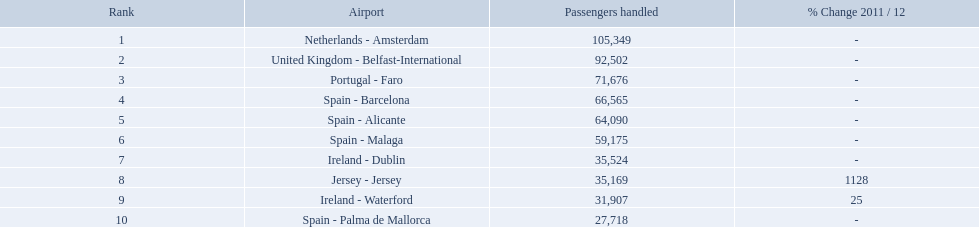Can you parse all the data within this table? {'header': ['Rank', 'Airport', 'Passengers handled', '% Change 2011 / 12'], 'rows': [['1', 'Netherlands - Amsterdam', '105,349', '-'], ['2', 'United Kingdom - Belfast-International', '92,502', '-'], ['3', 'Portugal - Faro', '71,676', '-'], ['4', 'Spain - Barcelona', '66,565', '-'], ['5', 'Spain - Alicante', '64,090', '-'], ['6', 'Spain - Malaga', '59,175', '-'], ['7', 'Ireland - Dublin', '35,524', '-'], ['8', 'Jersey - Jersey', '35,169', '1128'], ['9', 'Ireland - Waterford', '31,907', '25'], ['10', 'Spain - Palma de Mallorca', '27,718', '-']]} What are the airports? Netherlands - Amsterdam, United Kingdom - Belfast-International, Portugal - Faro, Spain - Barcelona, Spain - Alicante, Spain - Malaga, Ireland - Dublin, Jersey - Jersey, Ireland - Waterford, Spain - Palma de Mallorca. Of these which has the least amount of passengers? Spain - Palma de Mallorca. Which airports had passengers going through london southend airport? Netherlands - Amsterdam, United Kingdom - Belfast-International, Portugal - Faro, Spain - Barcelona, Spain - Alicante, Spain - Malaga, Ireland - Dublin, Jersey - Jersey, Ireland - Waterford, Spain - Palma de Mallorca. Of those airports, which airport had the least amount of passengers going through london southend airport? Spain - Palma de Mallorca. What are all of the airports? Netherlands - Amsterdam, United Kingdom - Belfast-International, Portugal - Faro, Spain - Barcelona, Spain - Alicante, Spain - Malaga, Ireland - Dublin, Jersey - Jersey, Ireland - Waterford, Spain - Palma de Mallorca. How many passengers have they handled? 105,349, 92,502, 71,676, 66,565, 64,090, 59,175, 35,524, 35,169, 31,907, 27,718. And which airport has handled the most passengers? Netherlands - Amsterdam. Which airports are in europe? Netherlands - Amsterdam, United Kingdom - Belfast-International, Portugal - Faro, Spain - Barcelona, Spain - Alicante, Spain - Malaga, Ireland - Dublin, Ireland - Waterford, Spain - Palma de Mallorca. Which one is from portugal? Portugal - Faro. What are all the airports in the top 10 busiest routes to and from london southend airport? Netherlands - Amsterdam, United Kingdom - Belfast-International, Portugal - Faro, Spain - Barcelona, Spain - Alicante, Spain - Malaga, Ireland - Dublin, Jersey - Jersey, Ireland - Waterford, Spain - Palma de Mallorca. Which airports are in portugal? Portugal - Faro. Would you be able to parse every entry in this table? {'header': ['Rank', 'Airport', 'Passengers handled', '% Change 2011 / 12'], 'rows': [['1', 'Netherlands - Amsterdam', '105,349', '-'], ['2', 'United Kingdom - Belfast-International', '92,502', '-'], ['3', 'Portugal - Faro', '71,676', '-'], ['4', 'Spain - Barcelona', '66,565', '-'], ['5', 'Spain - Alicante', '64,090', '-'], ['6', 'Spain - Malaga', '59,175', '-'], ['7', 'Ireland - Dublin', '35,524', '-'], ['8', 'Jersey - Jersey', '35,169', '1128'], ['9', 'Ireland - Waterford', '31,907', '25'], ['10', 'Spain - Palma de Mallorca', '27,718', '-']]} What is the highest number of passengers handled? 105,349. What is the destination of the passengers leaving the area that handles 105,349 travellers? Netherlands - Amsterdam. What are all of the routes out of the london southend airport? Netherlands - Amsterdam, United Kingdom - Belfast-International, Portugal - Faro, Spain - Barcelona, Spain - Alicante, Spain - Malaga, Ireland - Dublin, Jersey - Jersey, Ireland - Waterford, Spain - Palma de Mallorca. How many passengers have traveled to each destination? 105,349, 92,502, 71,676, 66,565, 64,090, 59,175, 35,524, 35,169, 31,907, 27,718. And which destination has been the most popular to passengers? Netherlands - Amsterdam. What is the highest number of passengers handled? 105,349. What is the destination of the passengers leaving the area that handles 105,349 travellers? Netherlands - Amsterdam. How many passengers did the united kingdom handle? 92,502. Who handled more passengers than this? Netherlands - Amsterdam. What are the appellations of all the airports? Netherlands - Amsterdam, United Kingdom - Belfast-International, Portugal - Faro, Spain - Barcelona, Spain - Alicante, Spain - Malaga, Ireland - Dublin, Jersey - Jersey, Ireland - Waterford, Spain - Palma de Mallorca. Of these, what are the complete passenger quantities? 105,349, 92,502, 71,676, 66,565, 64,090, 59,175, 35,524, 35,169, 31,907, 27,718. Of these, which airport had a greater number of passengers than the united kingdom? Netherlands - Amsterdam. Which airports had travelers passing through london southend airport? Netherlands - Amsterdam, United Kingdom - Belfast-International, Portugal - Faro, Spain - Barcelona, Spain - Alicante, Spain - Malaga, Ireland - Dublin, Jersey - Jersey, Ireland - Waterford, Spain - Palma de Mallorca. Among those airports, which one had the smallest number of passengers passing through london southend airport? Spain - Palma de Mallorca. What are the airports? Netherlands - Amsterdam, United Kingdom - Belfast-International, Portugal - Faro, Spain - Barcelona, Spain - Alicante, Spain - Malaga, Ireland - Dublin, Jersey - Jersey, Ireland - Waterford, Spain - Palma de Mallorca. Among them, which has the smallest volume of passengers? Spain - Palma de Mallorca. What is the highest rank? 1. What is the airstrip? Netherlands - Amsterdam. Could you help me parse every detail presented in this table? {'header': ['Rank', 'Airport', 'Passengers handled', '% Change 2011 / 12'], 'rows': [['1', 'Netherlands - Amsterdam', '105,349', '-'], ['2', 'United Kingdom - Belfast-International', '92,502', '-'], ['3', 'Portugal - Faro', '71,676', '-'], ['4', 'Spain - Barcelona', '66,565', '-'], ['5', 'Spain - Alicante', '64,090', '-'], ['6', 'Spain - Malaga', '59,175', '-'], ['7', 'Ireland - Dublin', '35,524', '-'], ['8', 'Jersey - Jersey', '35,169', '1128'], ['9', 'Ireland - Waterford', '31,907', '25'], ['10', 'Spain - Palma de Mallorca', '27,718', '-']]} How many individuals did the united kingdom process as passengers? 92,502. Who processed more passengers than this? Netherlands - Amsterdam. What are every destination from the london southend airport? Netherlands - Amsterdam, United Kingdom - Belfast-International, Portugal - Faro, Spain - Barcelona, Spain - Alicante, Spain - Malaga, Ireland - Dublin, Jersey - Jersey, Ireland - Waterford, Spain - Palma de Mallorca. How many individuals have been handled by each destination? 105,349, 92,502, 71,676, 66,565, 64,090, 59,175, 35,524, 35,169, 31,907, 27,718. And from those, which airport dealt with the smallest number of passengers? Spain - Palma de Mallorca. What is the greatest number of passengers dealt with? 105,349. What is the target location of the passengers leaving the region that processes 105,349 journeyers? Netherlands - Amsterdam. What are all the airports? Netherlands - Amsterdam, United Kingdom - Belfast-International, Portugal - Faro, Spain - Barcelona, Spain - Alicante, Spain - Malaga, Ireland - Dublin, Jersey - Jersey, Ireland - Waterford, Spain - Palma de Mallorca. How many passengers have they managed? 105,349, 92,502, 71,676, 66,565, 64,090, 59,175, 35,524, 35,169, 31,907, 27,718. And which airport has managed the most passengers? Netherlands - Amsterdam. What is the complete list of airports? Netherlands - Amsterdam, United Kingdom - Belfast-International, Portugal - Faro, Spain - Barcelona, Spain - Alicante, Spain - Malaga, Ireland - Dublin, Jersey - Jersey, Ireland - Waterford, Spain - Palma de Mallorca. What is the total number of passengers they have accommodated? 105,349, 92,502, 71,676, 66,565, 64,090, 59,175, 35,524, 35,169, 31,907, 27,718. And which airport has managed the highest number of passengers? Netherlands - Amsterdam. Can you provide a list of all airports? Netherlands - Amsterdam, United Kingdom - Belfast-International, Portugal - Faro, Spain - Barcelona, Spain - Alicante, Spain - Malaga, Ireland - Dublin, Jersey - Jersey, Ireland - Waterford, Spain - Palma de Mallorca. How many passengers have they served in total? 105,349, 92,502, 71,676, 66,565, 64,090, 59,175, 35,524, 35,169, 31,907, 27,718. And which airport has catered to the largest number of passengers? Netherlands - Amsterdam. Which airports can be found on the 10 busiest routes to and from london southend airport? Netherlands - Amsterdam, United Kingdom - Belfast-International, Portugal - Faro, Spain - Barcelona, Spain - Alicante, Spain - Malaga, Ireland - Dublin, Jersey - Jersey, Ireland - Waterford, Spain - Palma de Mallorca. Also, which airports are located in portugal? Portugal - Faro. What is the highest ranking? 1. What is the airfield? Netherlands - Amsterdam. Write the full table. {'header': ['Rank', 'Airport', 'Passengers handled', '% Change 2011 / 12'], 'rows': [['1', 'Netherlands - Amsterdam', '105,349', '-'], ['2', 'United Kingdom - Belfast-International', '92,502', '-'], ['3', 'Portugal - Faro', '71,676', '-'], ['4', 'Spain - Barcelona', '66,565', '-'], ['5', 'Spain - Alicante', '64,090', '-'], ['6', 'Spain - Malaga', '59,175', '-'], ['7', 'Ireland - Dublin', '35,524', '-'], ['8', 'Jersey - Jersey', '35,169', '1128'], ['9', 'Ireland - Waterford', '31,907', '25'], ['10', 'Spain - Palma de Mallorca', '27,718', '-']]} What is the optimum status? 1. What is the flight terminal? Netherlands - Amsterdam. What is the greatest number of passengers accommodated? 105,349. What is the endpoint for passengers leaving the region handling 105,349 individuals? Netherlands - Amsterdam. 